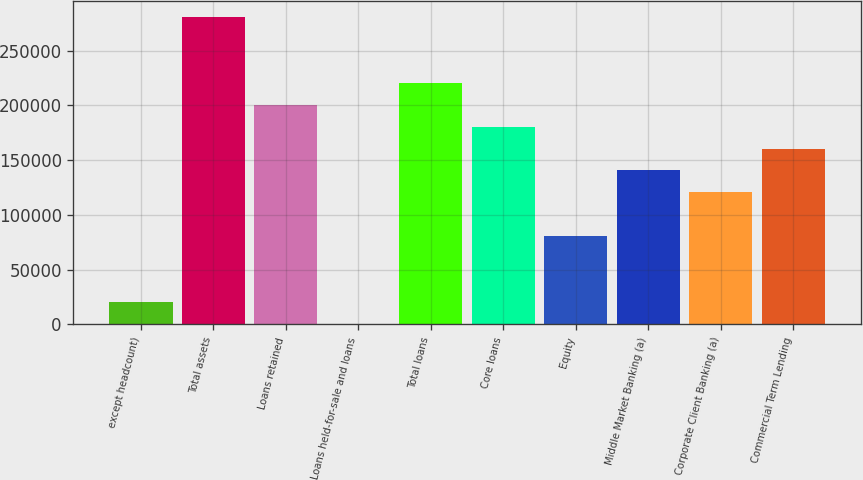Convert chart. <chart><loc_0><loc_0><loc_500><loc_500><bar_chart><fcel>except headcount)<fcel>Total assets<fcel>Loans retained<fcel>Loans held-for-sale and loans<fcel>Total loans<fcel>Core loans<fcel>Equity<fcel>Middle Market Banking (a)<fcel>Corporate Client Banking (a)<fcel>Commercial Term Lending<nl><fcel>20310.3<fcel>280873<fcel>200700<fcel>267<fcel>220743<fcel>180657<fcel>80440.2<fcel>140570<fcel>120527<fcel>160613<nl></chart> 